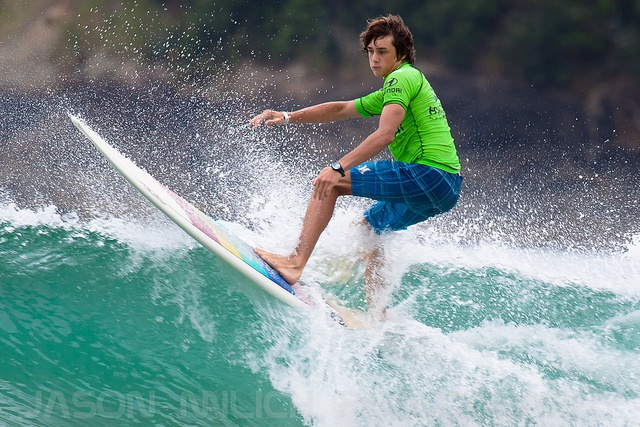Describe the objects in this image and their specific colors. I can see people in gray, brown, navy, and lightgray tones and surfboard in gray, lightgray, lightpink, darkgray, and lightblue tones in this image. 